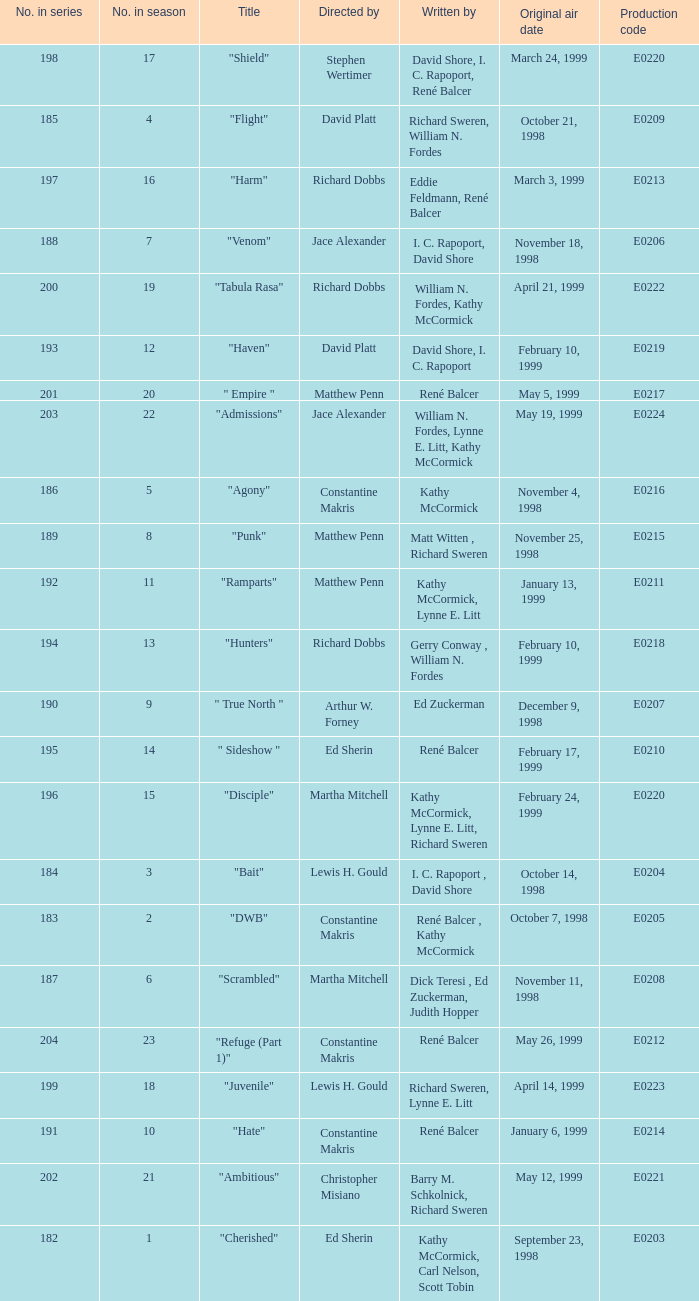The episode with the original air date January 6, 1999, has what production code? E0214. 